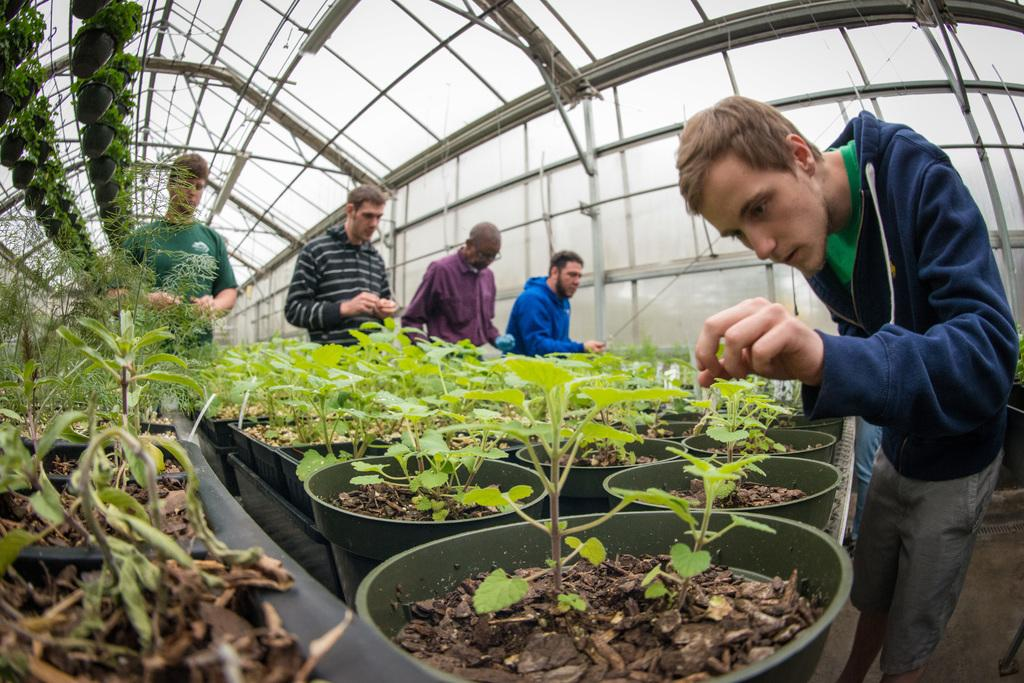What type of plants can be seen in the image? There are house plants in the image. How many men are standing in the image? There are five men standing in the image. What can be seen in the background of the image? There are rods and a shed visible in the background of the image. What type of umbrella is being used to weigh down the plants in the image? There is no umbrella present in the image, and the plants are not being weighed down. 